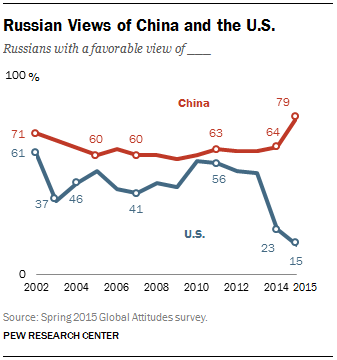Indicate a few pertinent items in this graphic. The average of all values below 30 is 19. The color of the graph with the lowest value of 15 is blue. 